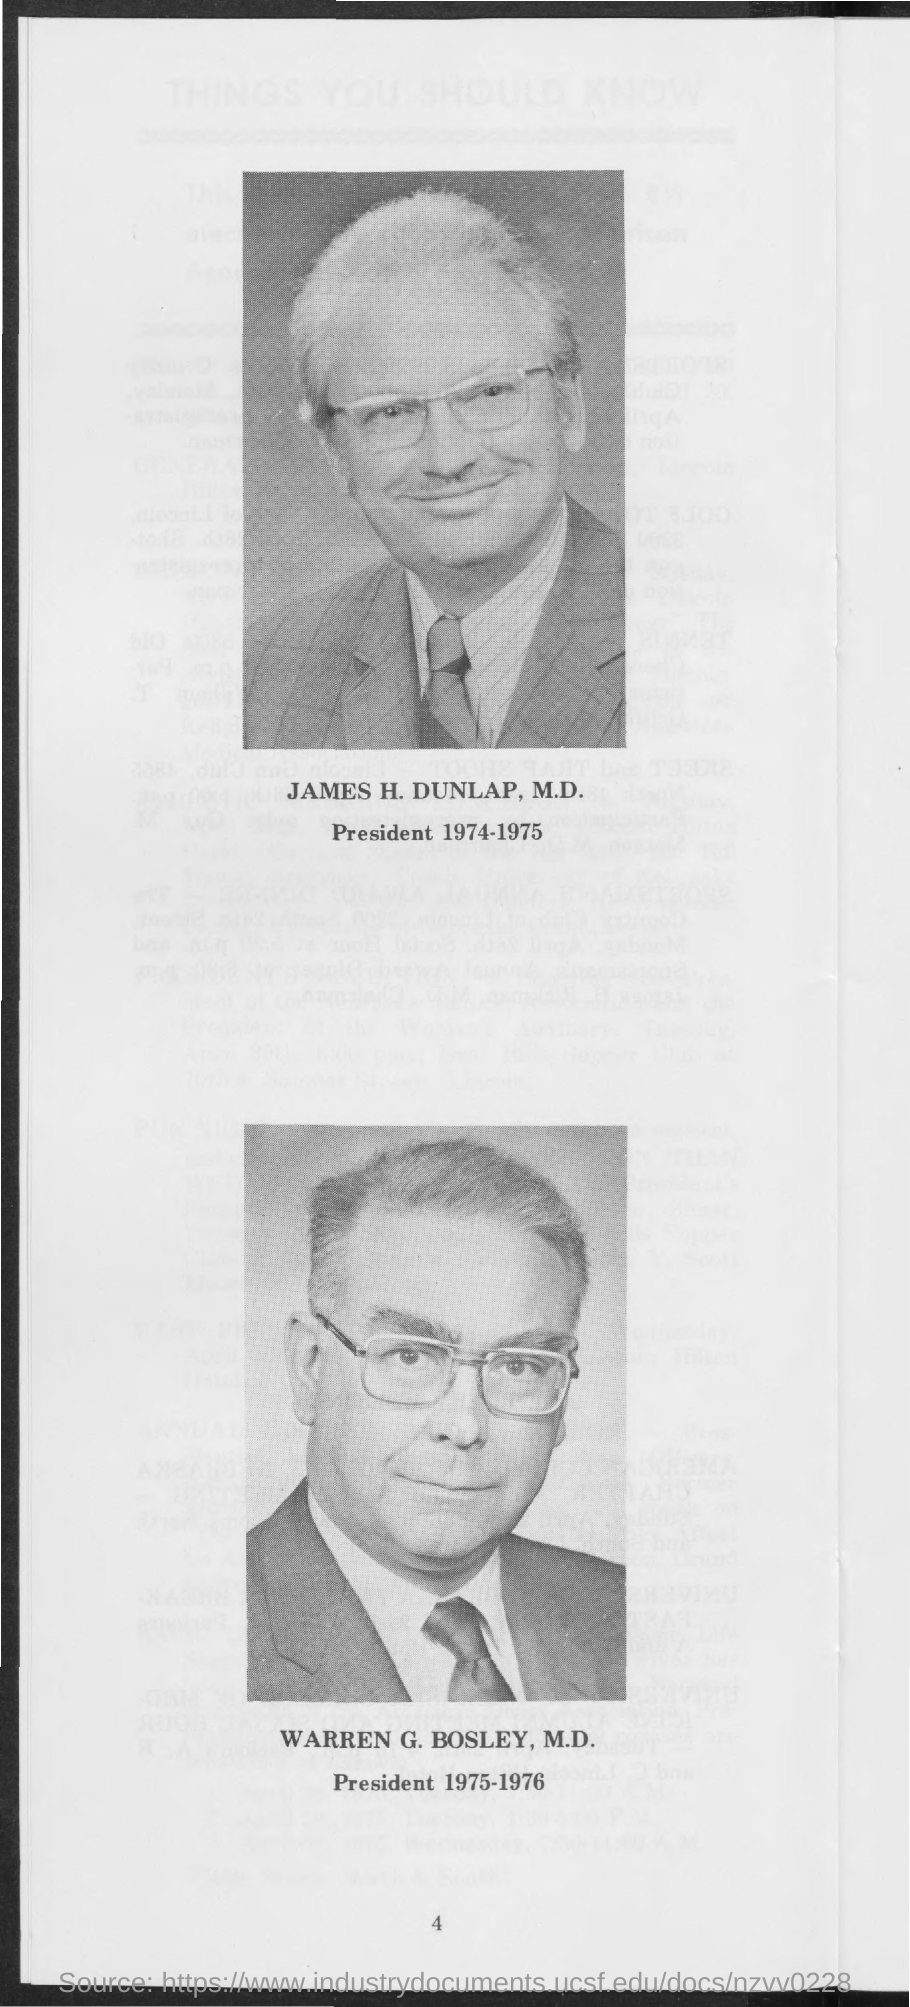Who is the president during the year 1974-1975?
Ensure brevity in your answer.  JAMES H. DUNLAP, M.D. Who is the president during the year 1975-1976?
Your answer should be very brief. WARREN G. BOSLEY, M.D. 